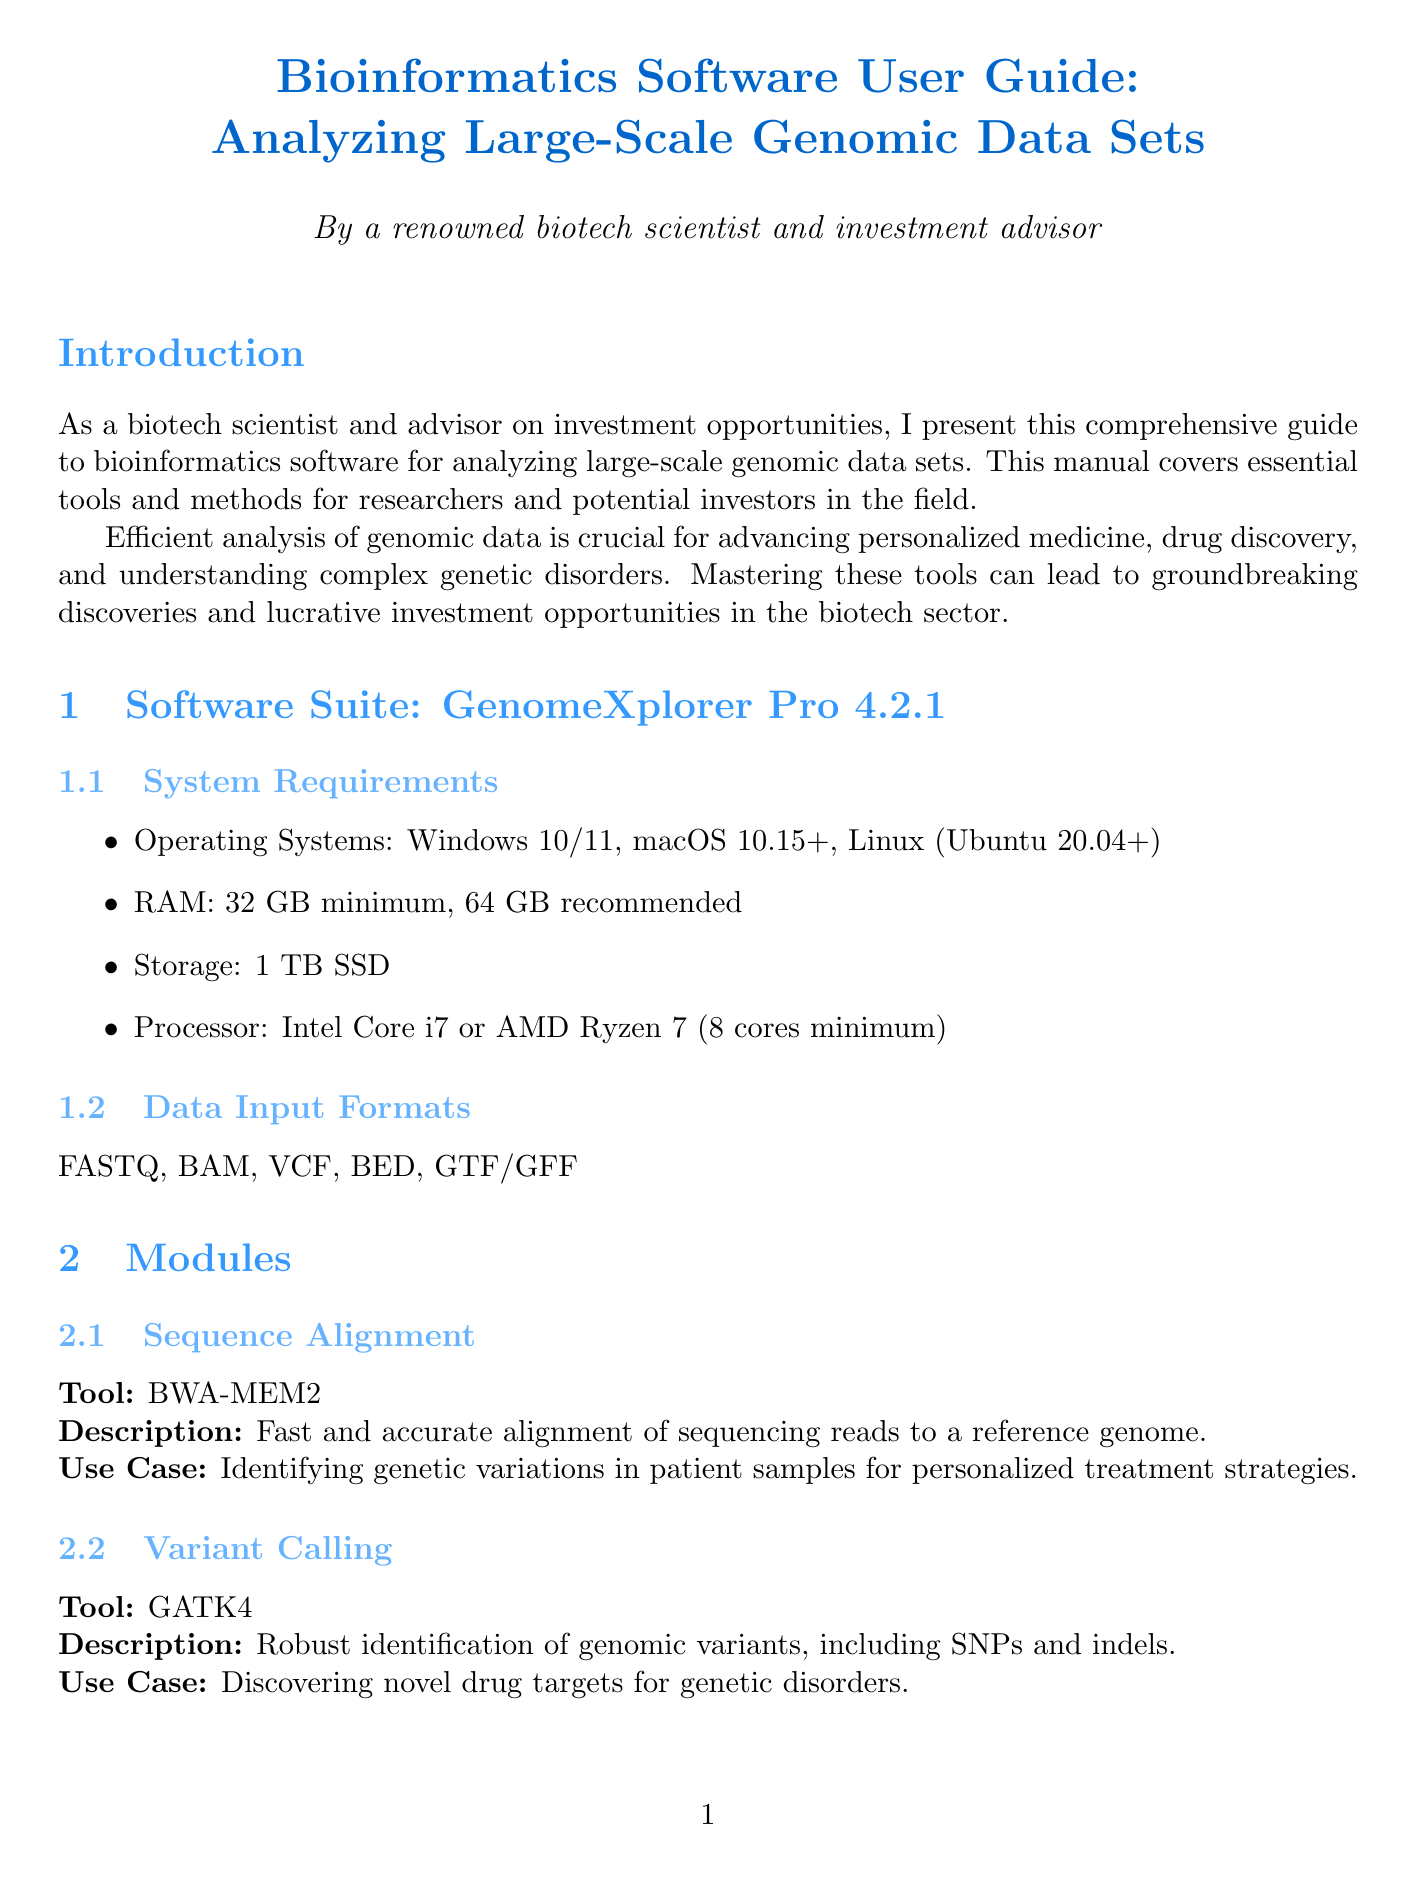What is the name of the software suite? The software suite is named "GenomeXplorer Pro".
Answer: GenomeXplorer Pro What is the current version of the software? The document specifies that the version of the software suite is 4.2.1.
Answer: 4.2.1 How much RAM is recommended for the software? The recommended RAM for the software is stated in the system requirements section as "64 GB".
Answer: 64 GB Which tool is used for variant calling? The module for variant calling lists "GATK4" as the tool used.
Answer: GATK4 What is the main use case for DESeq2? The use case describes identifying biomarkers for early cancer detection using DESeq2.
Answer: Identifying biomarkers for early cancer detection What kind of analysis does PCA apply to? The application states that PCA is used for "Dimensionality reduction and population structure analysis".
Answer: Dimensionality reduction and population structure analysis Which visualization tool offers whole-genome visualization? The document mentions "Circos" as a tool that provides whole-genome visualization.
Answer: Circos What is a high growth area mentioned in the advanced topics? The document identifies "Machine Learning in Genomics" as a high growth area.
Answer: Machine Learning in Genomics What is the first best practice listed in the document? The first best practice emphasizes rigorous quality control measures at each step of the analysis pipeline.
Answer: Implement rigorous quality control measures at each step of the analysis pipeline 